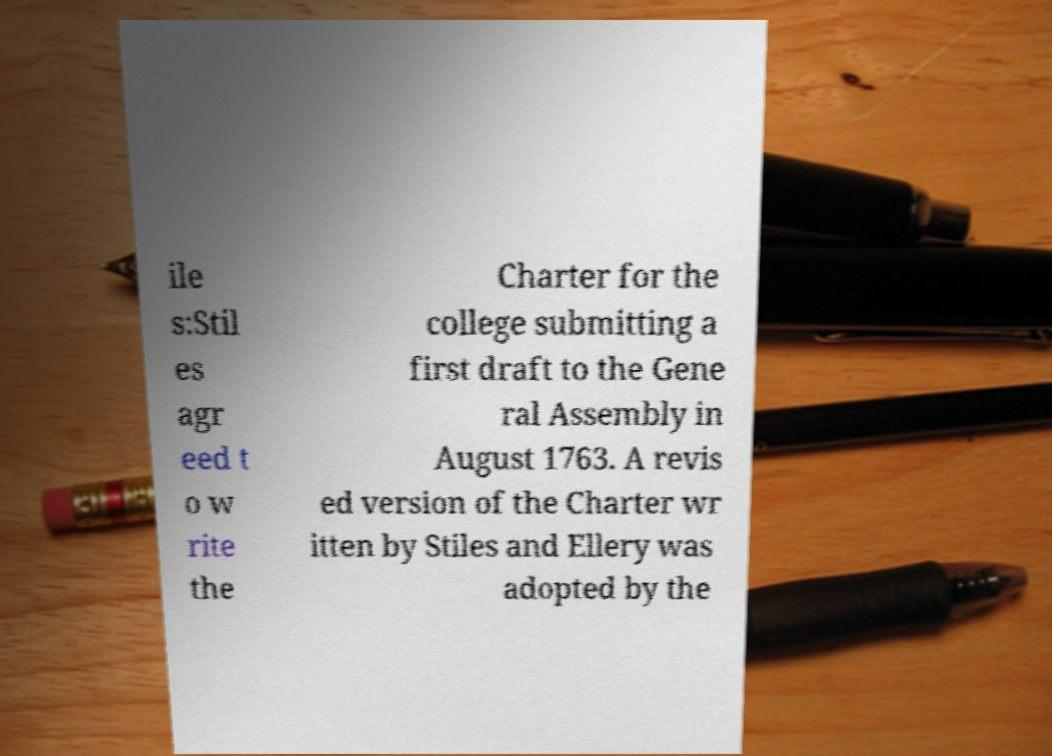Could you assist in decoding the text presented in this image and type it out clearly? ile s:Stil es agr eed t o w rite the Charter for the college submitting a first draft to the Gene ral Assembly in August 1763. A revis ed version of the Charter wr itten by Stiles and Ellery was adopted by the 